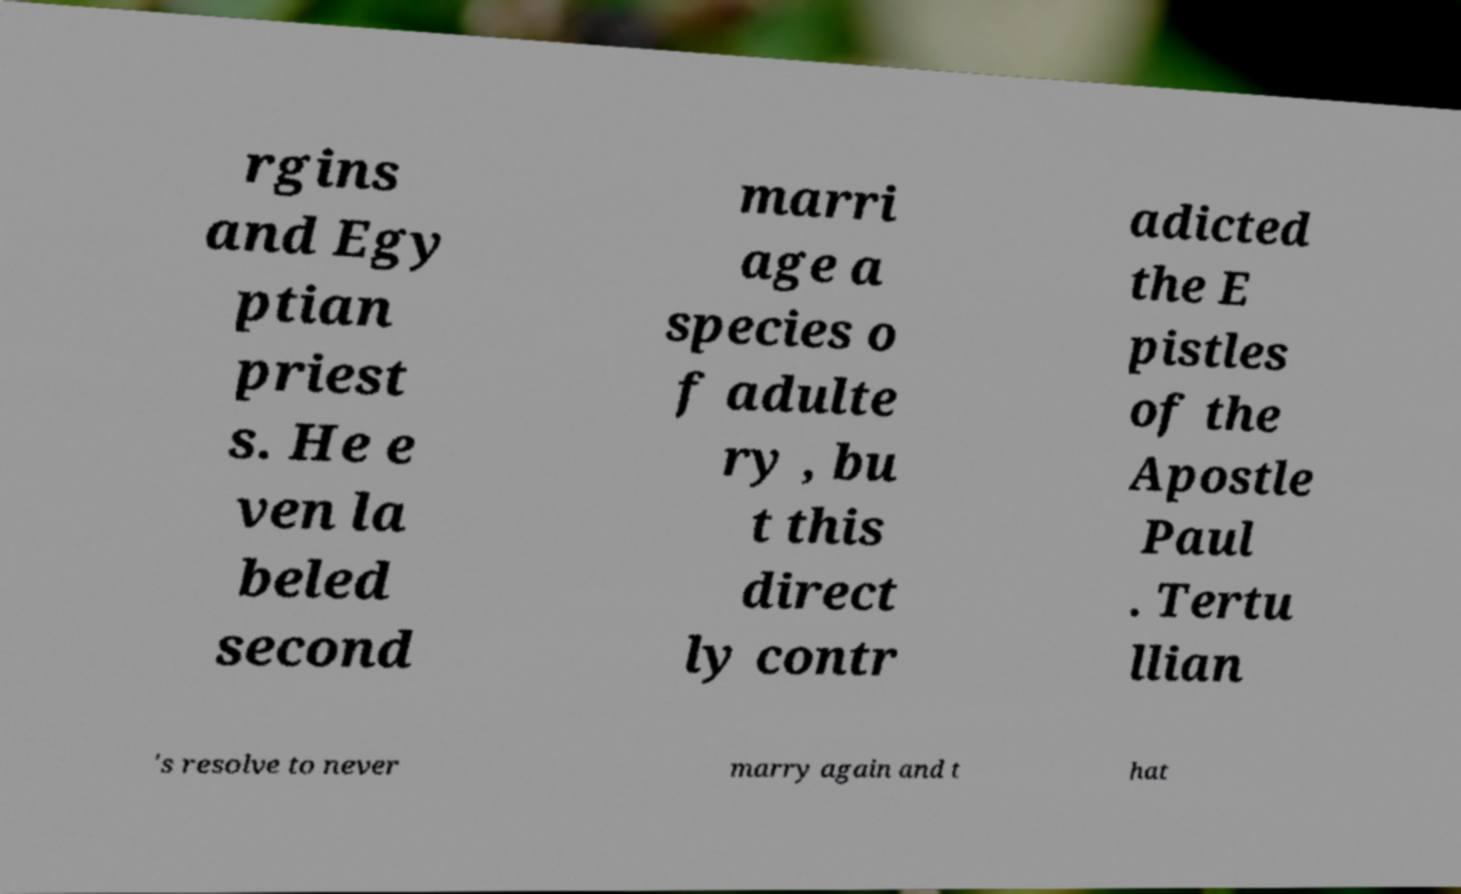Please read and relay the text visible in this image. What does it say? rgins and Egy ptian priest s. He e ven la beled second marri age a species o f adulte ry , bu t this direct ly contr adicted the E pistles of the Apostle Paul . Tertu llian 's resolve to never marry again and t hat 